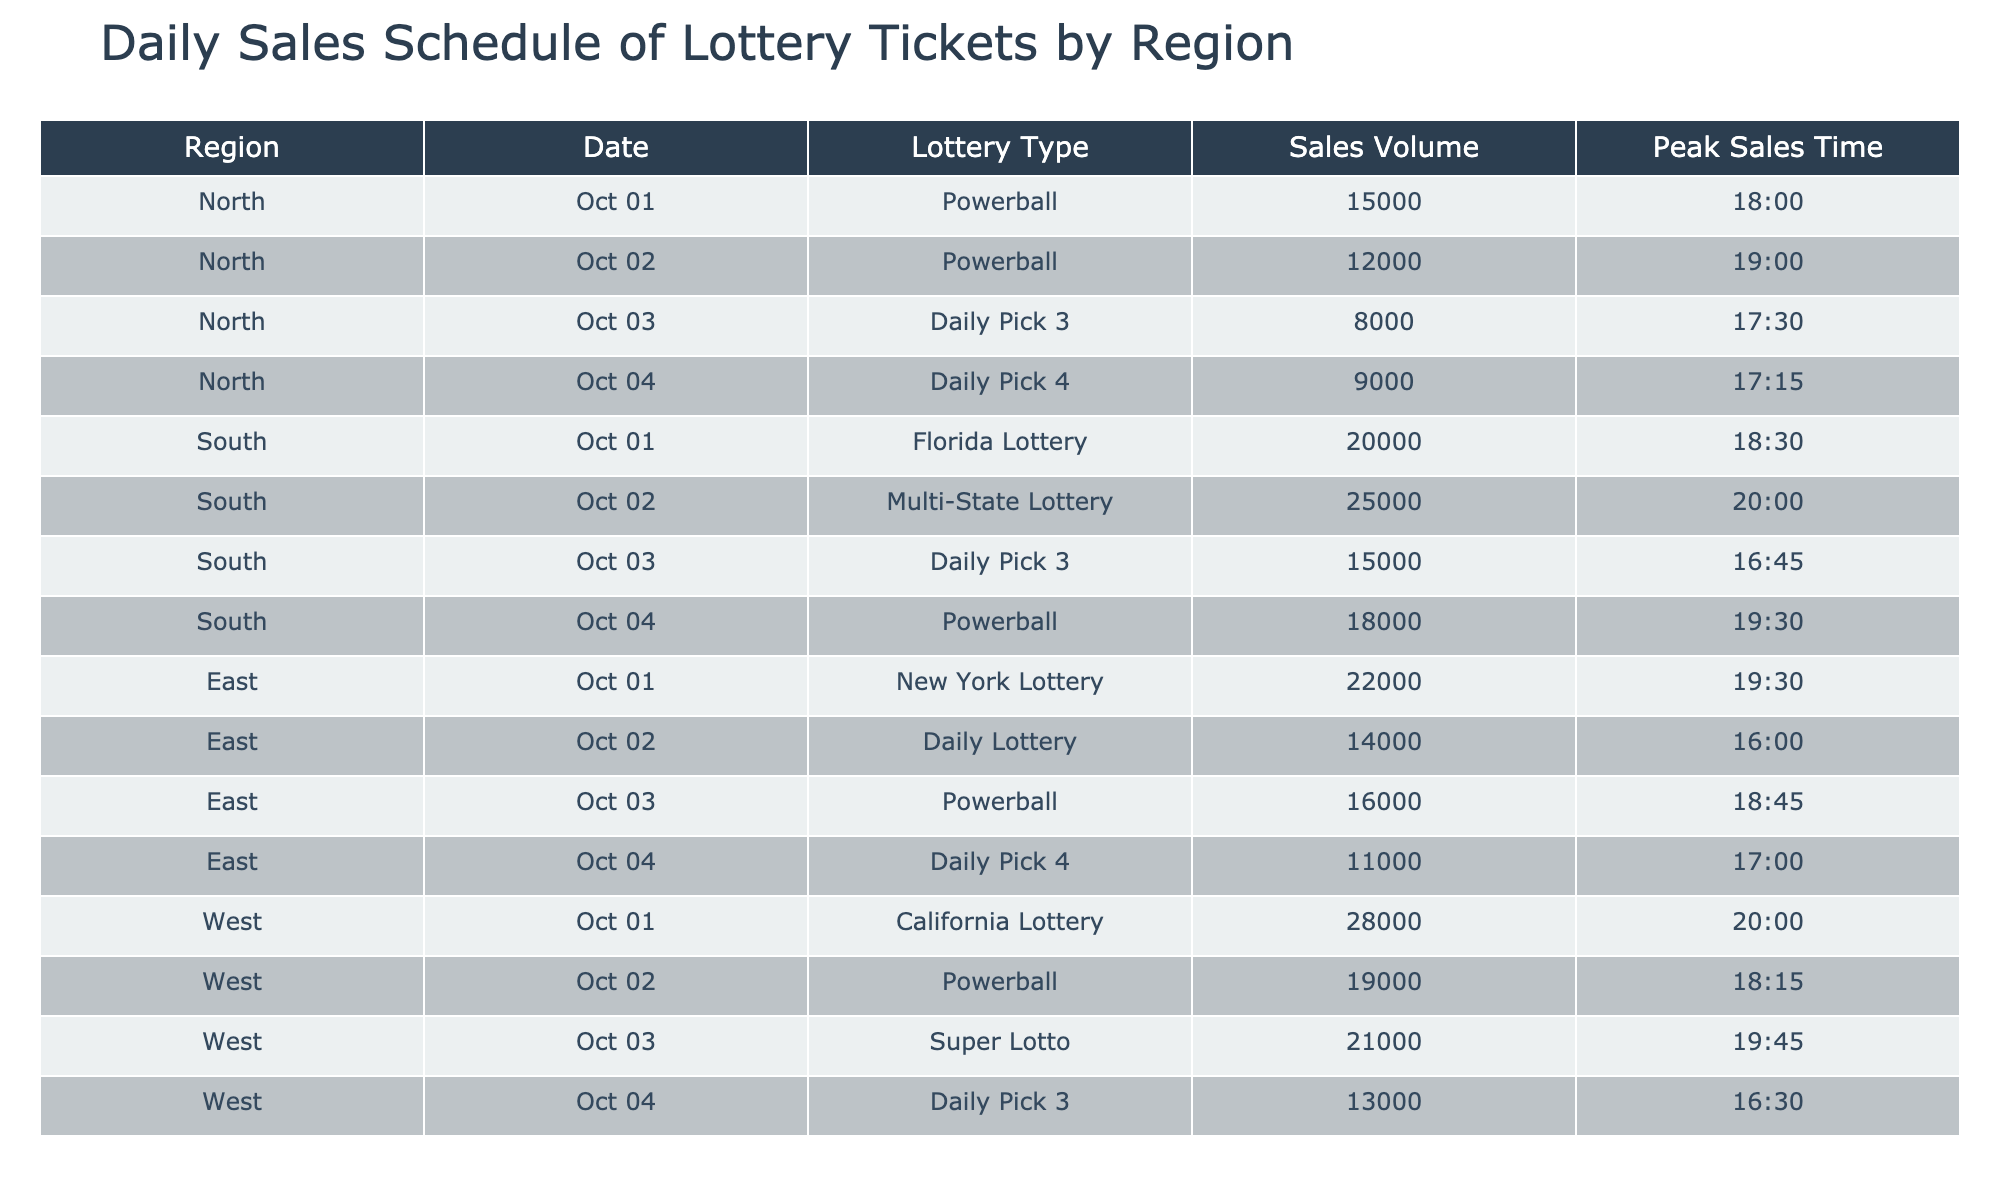What is the sales volume for the Powerball in the North region on October 2, 2023? Looking at the table, for the North region and the date October 2, 2023, the Lottery Type is Powerball, and the Sales Volume is listed as 12000.
Answer: 12000 What is the peak sales time for the Florida Lottery in the South region? Referring to the South region and the Florida Lottery entry, the peak sales time is noted as 18:30.
Answer: 18:30 Which region had the highest sales volume for the Daily Pick 3 on October 4, 2023? The Daily Pick 3 for October 4, 2023, is compared across regions: North has 8000, South has 15000, East has no sales listed, and West has 13000. South has the highest volume at 15000.
Answer: South What is the total sales volume of all lottery types in the West region on October 1, 2023? In the West region on October 1, 2023, the California Lottery has a sales volume of 28000, which is the only entry for that date in that region. So, the total is simply 28000.
Answer: 28000 Is the average sales volume for Daily Pick 3 higher in the North region than in the South region? For Daily Pick 3, North has 8000 on October 3, while South has 15000 on October 3. The average for North (8000) is lower than for South (15000), so the answer is no.
Answer: No What is the total sales volume for Powerball across all regions for the specified dates? Adding the sales volumes for Powerball: North (15000 on October 1 + 12000 on October 2), South (18000 on October 4), East (16000 on October 3), and West (19000 on October 2). So, total = 15000 + 12000 + 18000 + 16000 + 19000 = 90000.
Answer: 90000 Which lottery type had the lowest sales volume in the East region? In the East region entries, the lowest sales volumes are: New York Lottery (22000), Daily Lottery (14000), Powerball (16000), and Daily Pick 4 (11000). The Daily Pick 4 has the lowest volume at 11000.
Answer: Daily Pick 4 Was there any entry in the table with a sales volume above 25000? Checking through the table, the Florida Lottery in the South region had a sales volume of 20000 and the West region had California Lottery with 28000 on October 1. Therefore, there is indeed an entry above 25000 and it is 28000.
Answer: Yes On which date did the South region have its highest sales volume and what was the amount? In the South region, the entries are: 20000 on October 1, 25000 on October 2, 15000 on October 3, and 18000 on October 4. The highest volume was 25000 on October 2.
Answer: October 2, 25000 